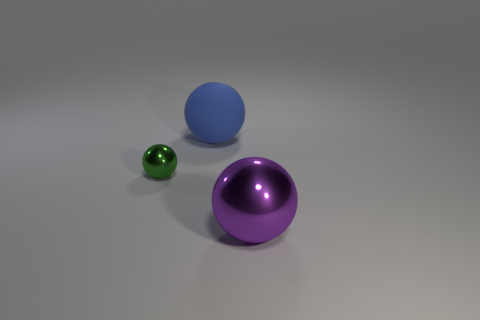Add 3 matte things. How many objects exist? 6 Subtract all big purple rubber balls. Subtract all spheres. How many objects are left? 0 Add 2 large spheres. How many large spheres are left? 4 Add 1 big purple shiny things. How many big purple shiny things exist? 2 Subtract 0 brown cylinders. How many objects are left? 3 